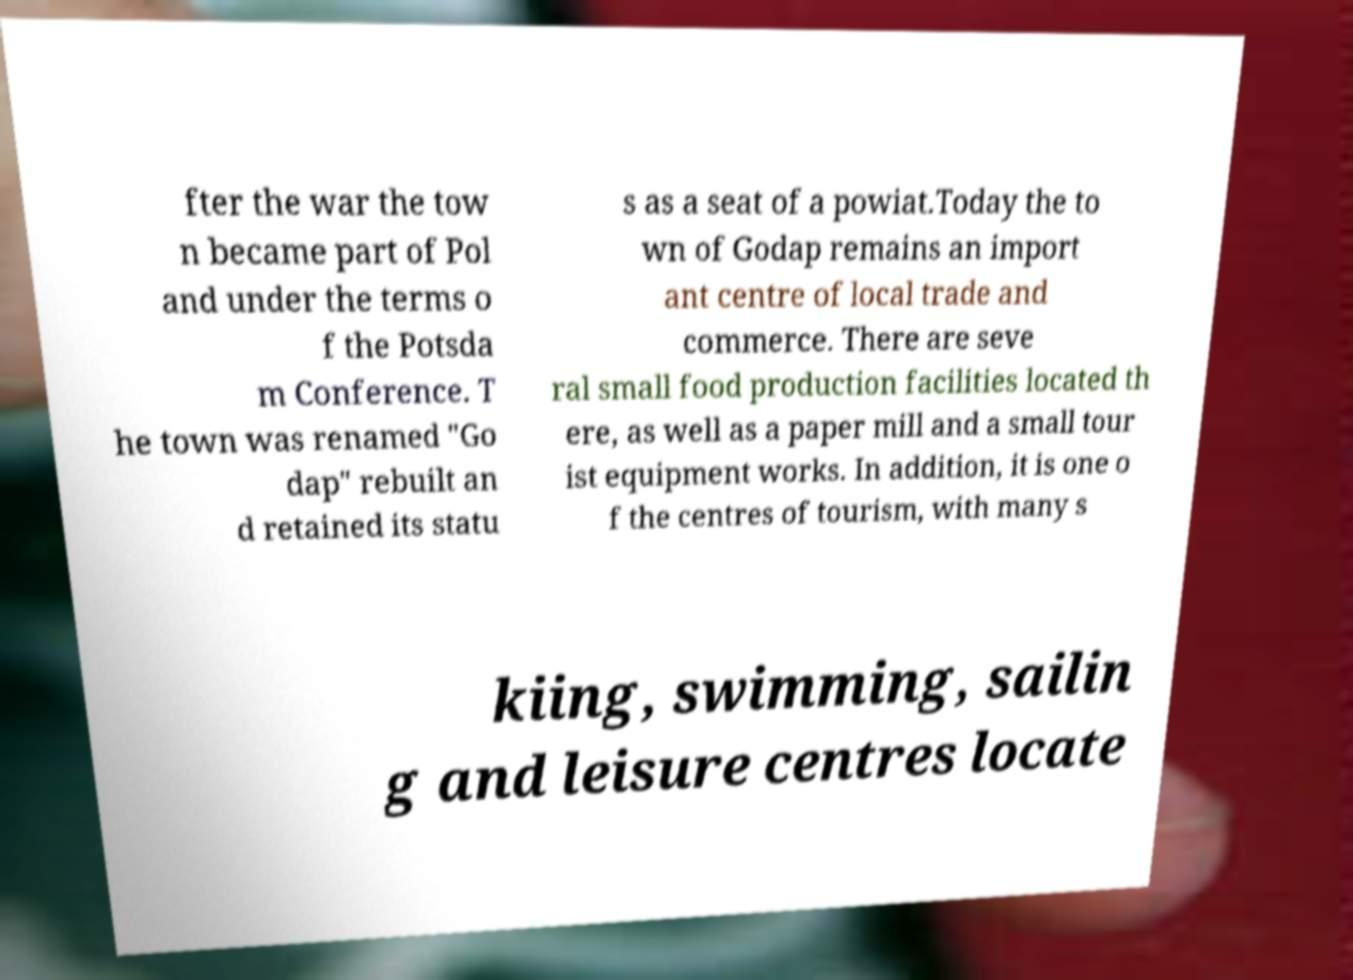There's text embedded in this image that I need extracted. Can you transcribe it verbatim? fter the war the tow n became part of Pol and under the terms o f the Potsda m Conference. T he town was renamed "Go dap" rebuilt an d retained its statu s as a seat of a powiat.Today the to wn of Godap remains an import ant centre of local trade and commerce. There are seve ral small food production facilities located th ere, as well as a paper mill and a small tour ist equipment works. In addition, it is one o f the centres of tourism, with many s kiing, swimming, sailin g and leisure centres locate 